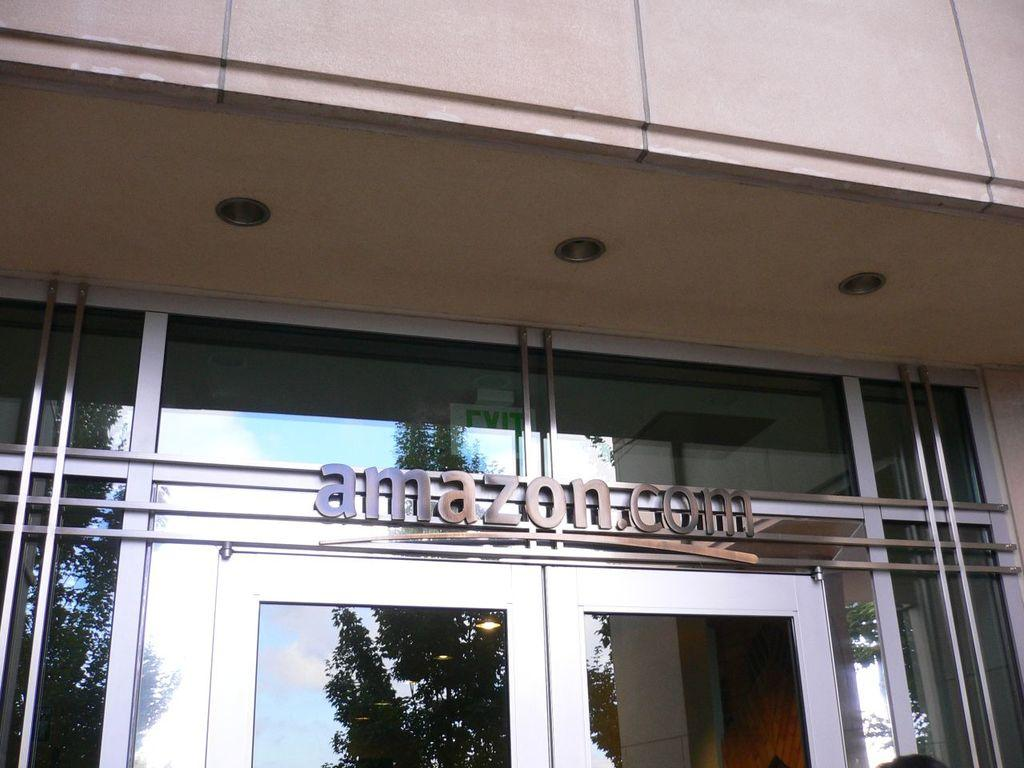What type of structure is present in the image? There is a building in the image. What feature can be seen on the building? There is a glass door on the building. Is there any signage on the glass door? Yes, there is a name board on the glass door. What can be seen in the reflection on the glass door? The reflection of trees is visible on the glass. Who is the coach of the team mentioned on the name board in the image? There is no team or coach mentioned on the name board in the image. 